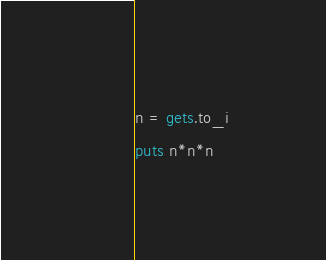Convert code to text. <code><loc_0><loc_0><loc_500><loc_500><_Ruby_>n = gets.to_i
puts n*n*n</code> 